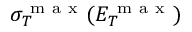<formula> <loc_0><loc_0><loc_500><loc_500>\sigma _ { T } ^ { m a x } ( E _ { T } ^ { m a x } )</formula> 